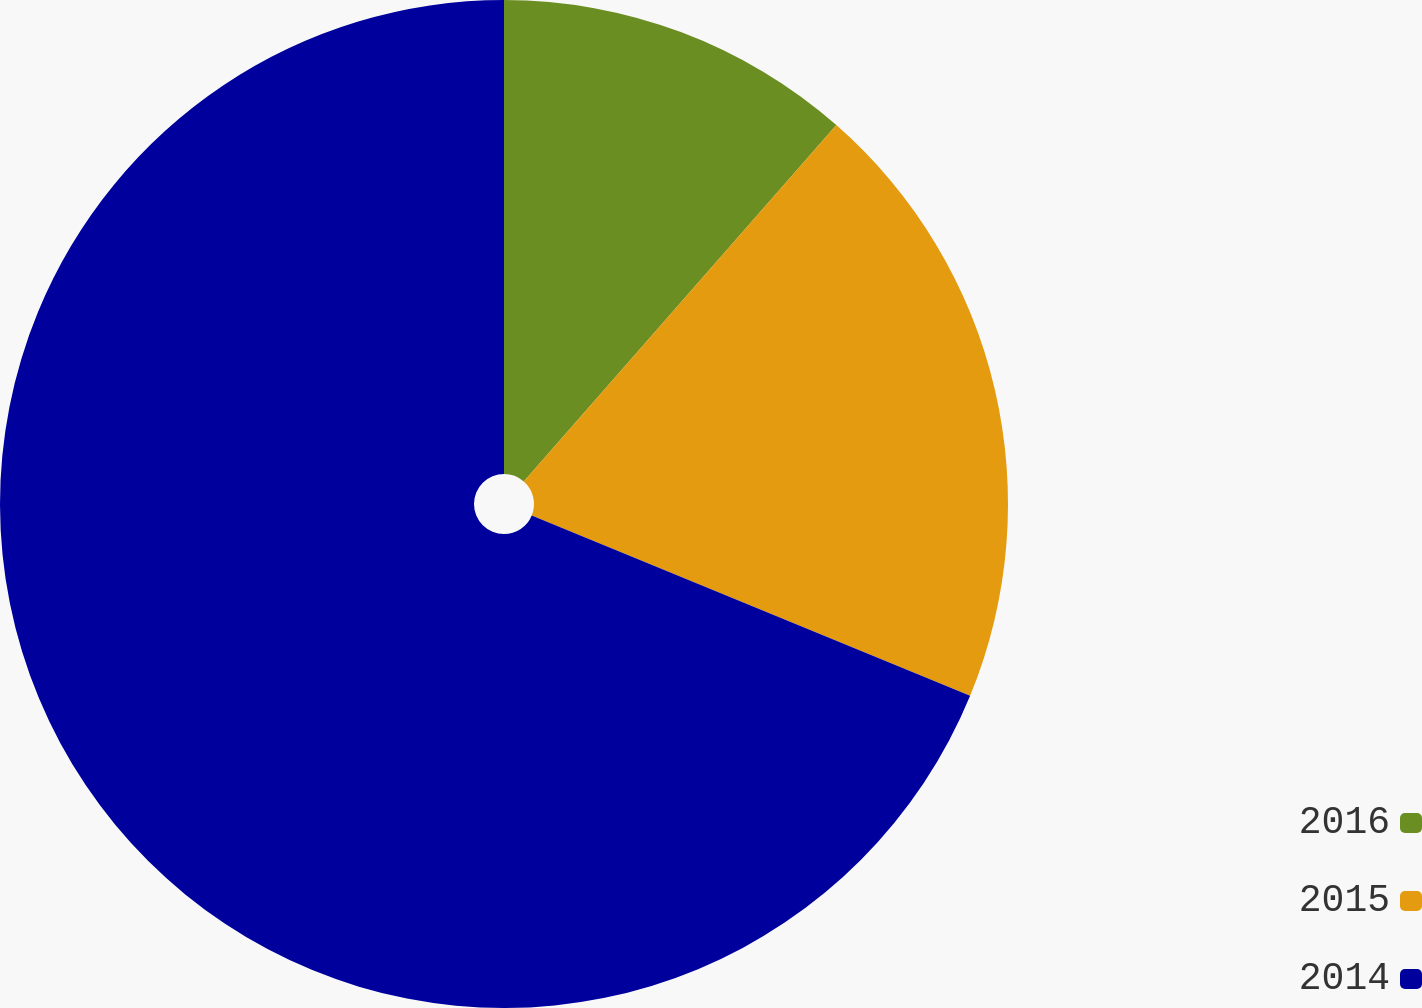Convert chart. <chart><loc_0><loc_0><loc_500><loc_500><pie_chart><fcel>2016<fcel>2015<fcel>2014<nl><fcel>11.46%<fcel>19.75%<fcel>68.79%<nl></chart> 